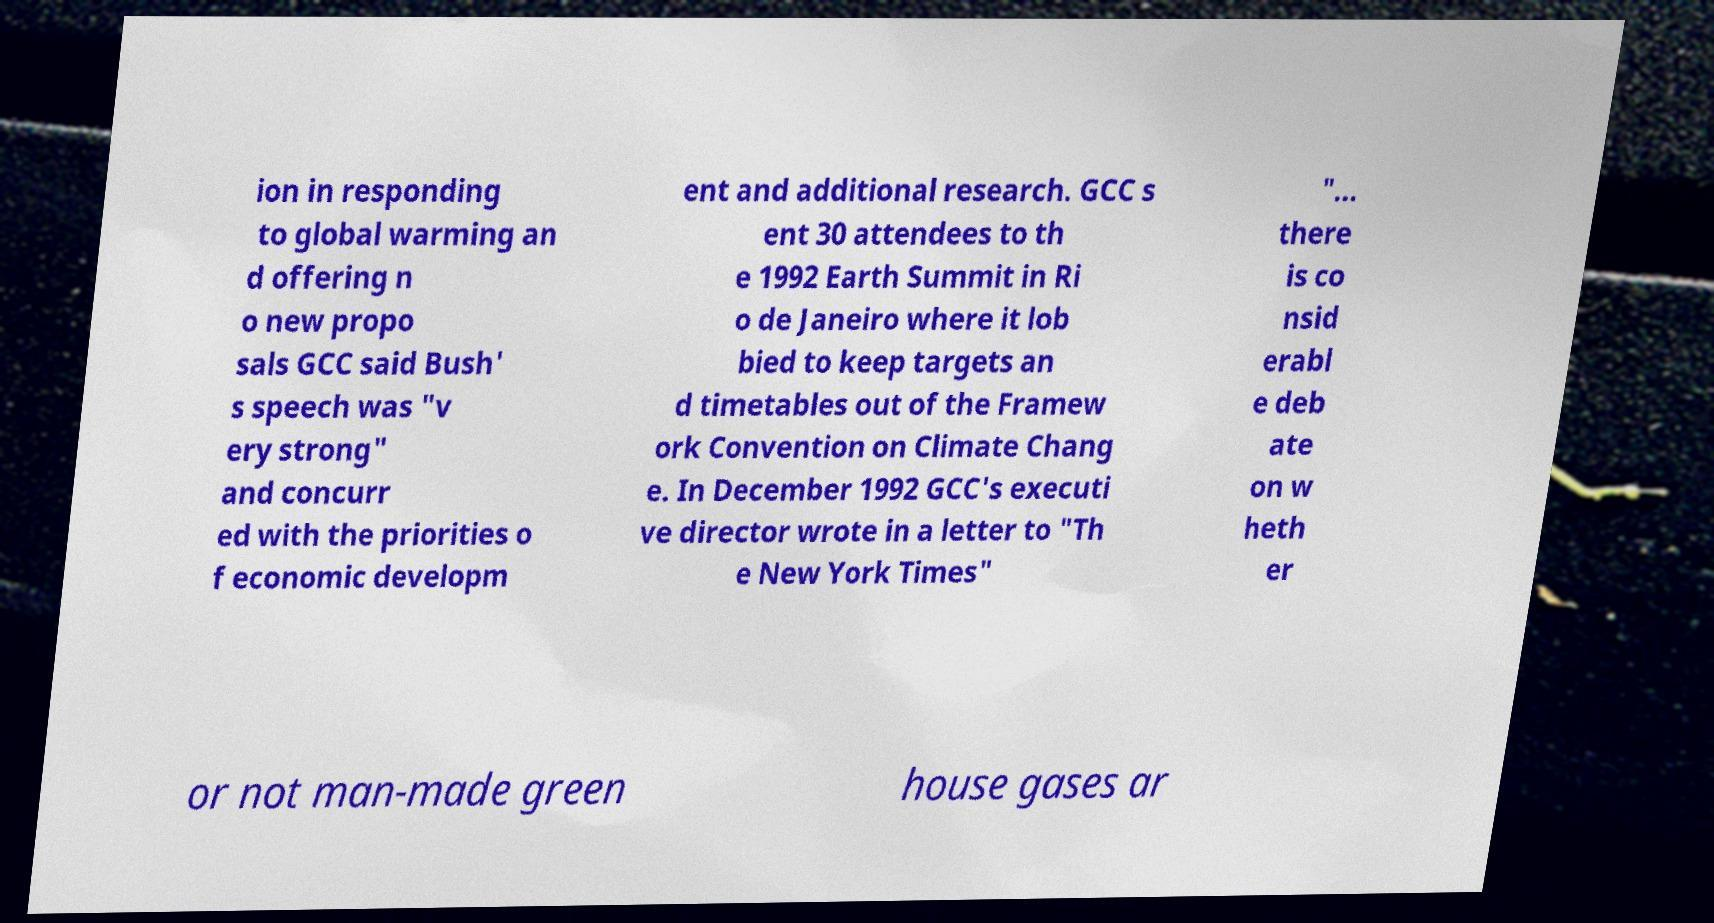For documentation purposes, I need the text within this image transcribed. Could you provide that? ion in responding to global warming an d offering n o new propo sals GCC said Bush' s speech was "v ery strong" and concurr ed with the priorities o f economic developm ent and additional research. GCC s ent 30 attendees to th e 1992 Earth Summit in Ri o de Janeiro where it lob bied to keep targets an d timetables out of the Framew ork Convention on Climate Chang e. In December 1992 GCC's executi ve director wrote in a letter to "Th e New York Times" "... there is co nsid erabl e deb ate on w heth er or not man-made green house gases ar 